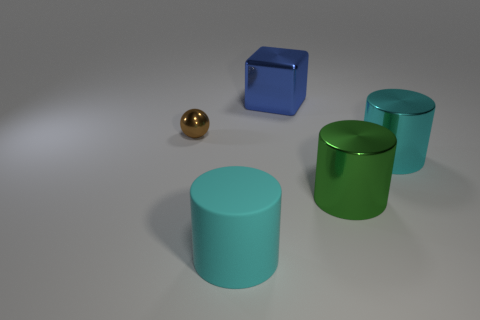Is the number of blue metal things in front of the small sphere the same as the number of metal spheres that are left of the blue shiny block?
Provide a short and direct response. No. There is a metal thing left of the big blue metal cube; is it the same size as the cyan object on the right side of the matte thing?
Provide a short and direct response. No. The metal thing on the left side of the big cylinder that is on the left side of the shiny thing behind the metallic ball is what shape?
Your answer should be compact. Sphere. Is there anything else that has the same material as the small brown thing?
Keep it short and to the point. Yes. What size is the green thing that is the same shape as the large cyan shiny object?
Provide a succinct answer. Large. What is the color of the large metallic object that is both on the left side of the big cyan shiny object and in front of the cube?
Give a very brief answer. Green. Do the brown thing and the large cyan cylinder behind the large cyan matte cylinder have the same material?
Make the answer very short. Yes. Are there fewer large matte cylinders that are on the right side of the matte cylinder than small metallic things?
Provide a short and direct response. Yes. What number of other things are the same shape as the large cyan rubber object?
Keep it short and to the point. 2. Is there anything else of the same color as the tiny object?
Your answer should be compact. No. 